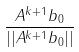<formula> <loc_0><loc_0><loc_500><loc_500>\frac { A ^ { k + 1 } b _ { 0 } } { | | A ^ { k + 1 } b _ { 0 } | | }</formula> 